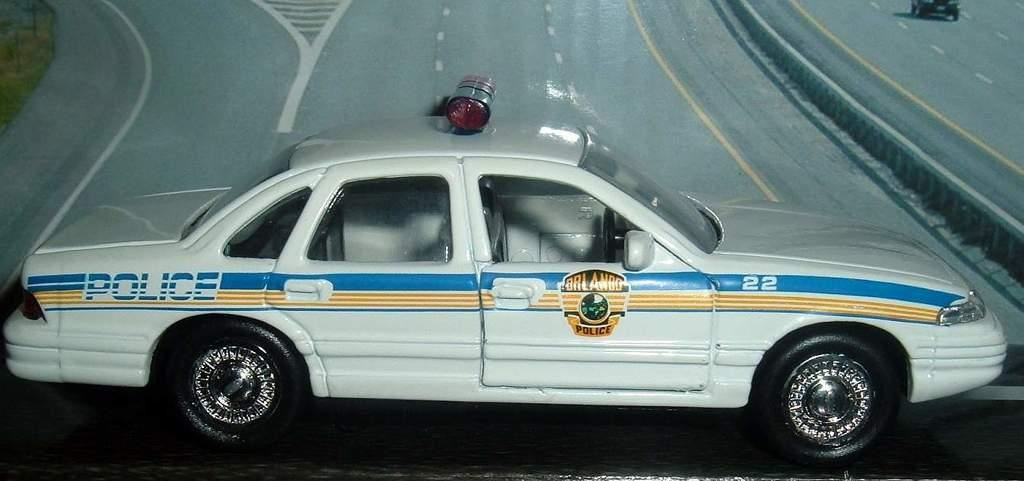What is the main subject of the image? There is a vehicle in the image. What can be seen in the background of the image? There are roads visible in the background of the image. Can you describe the object in the background? There is an object in the background of the image, but its specific details are not clear from the provided facts. What color is the surface at the bottom of the image? The surface at the bottom of the image is black. What decision is the vehicle making in the image? Vehicles do not make decisions; they are inanimate objects. --- Facts: 1. There is a person in the image. 2. The person is holding a book. 3. The person is sitting on a chair. 4. There is a table in the image. 5. The table has a lamp on it. Absurd Topics: dance, ocean, fish Conversation: Who is the main subject of the image? There is a person in the image. What is the person holding in the image? The person is holding a book. What is the person's position in the image? The person is sitting on a chair. What other object can be seen in the image? There is a table in the image. What is on the table? The table has a lamp on it. Reasoning: Let's think step by step in order to produce the conversation. We start by identifying the main subject of the image, which is the person. Then, we expand the conversation to include other elements visible in the image, such as the book, the chair, the table, and the lamp. Each question is designed to elicit a specific detail about the image that is known from the provided facts. Absurd Question/Answer: Can you see any fish swimming in the ocean in the image? There is no ocean or fish present in the image. 